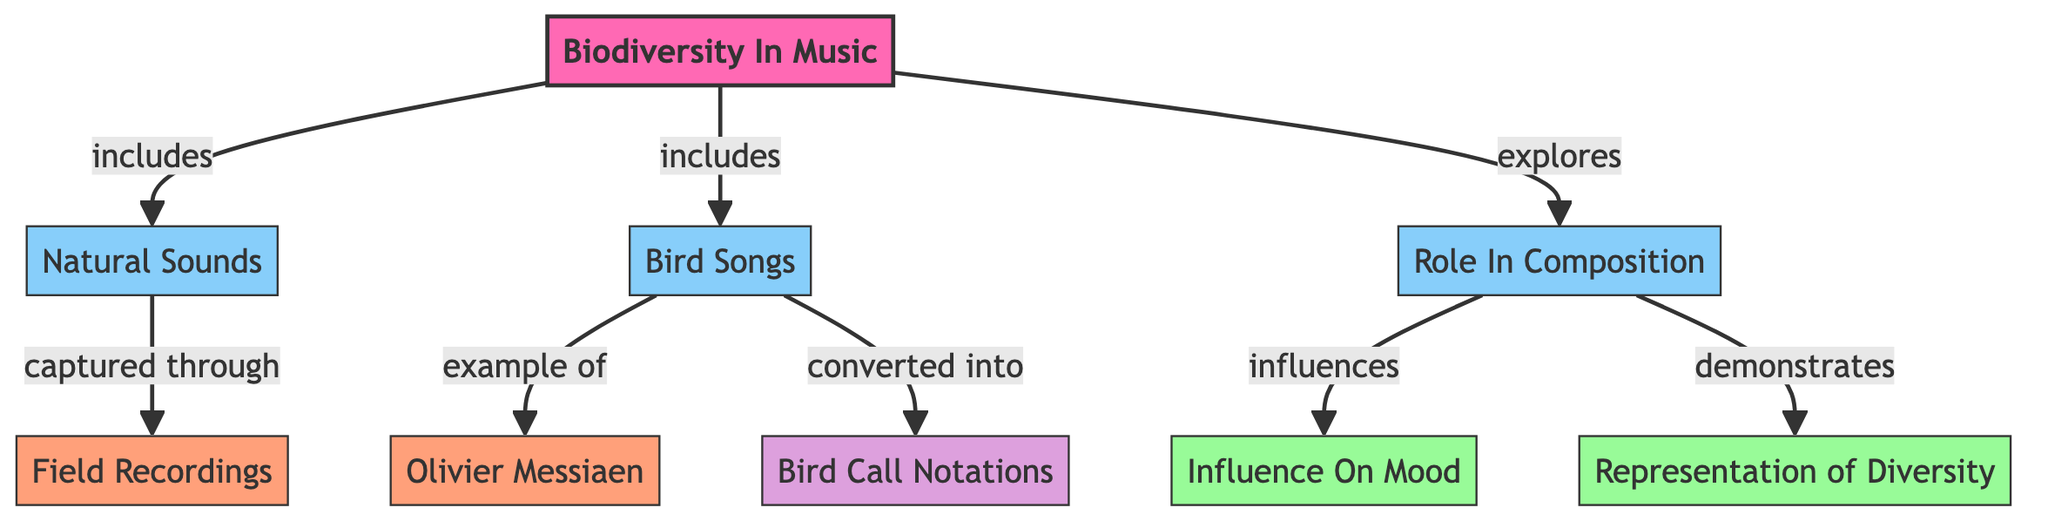What are the two main components of biodiversity in music? The diagram identifies "Natural Sounds" and "Bird Songs" as the two main components under the main topic "Biodiversity In Music."
Answer: Natural Sounds and Bird Songs What is the role of natural sounds and bird songs in music composition? The diagram shows that they "explore" "Role In Composition," meaning both elements influence how music is created.
Answer: Role In Composition Which element influences mood in music? The arrow indicates that "Role In Composition" directly influences "Influence On Mood" in the diagram, establishing a connection between composition and mood.
Answer: Influence On Mood What is the example given for bird songs? The diagram states that "Bird Songs" has an example of "Olivier Messiaen," illustrating how specific composers use bird songs in their work.
Answer: Olivier Messiaen How are natural sounds captured, according to the diagram? The diagram indicates that natural sounds are "captured through" field recordings, showcasing a method of obtaining these sounds for use in music.
Answer: Field Recordings How are bird songs converted in the context of music? The "Bird Songs" node points to "Bird Call Notations," showing that bird songs can be translated into notation for musicians to use.
Answer: Bird Call Notations What type of representation is demonstrated by the role of natural sounds and bird songs? According to the diagram, the "Role In Composition" "demonstrates" "Representation of Diversity," indicating how these elements reflect various species and habitats.
Answer: Representation of Diversity What is the significance of "Field Recordings" in the diagram? The diagram connects "Natural Sounds" to "Field Recordings," emphasizing their role in capturing sounds from nature for musical composition.
Answer: Captured Through Field Recordings What color signifies the main topic in this diagram? The main topic "Biodiversity In Music" is shown in pink, which is highlighted in the diagram for emphasis.
Answer: Pink 